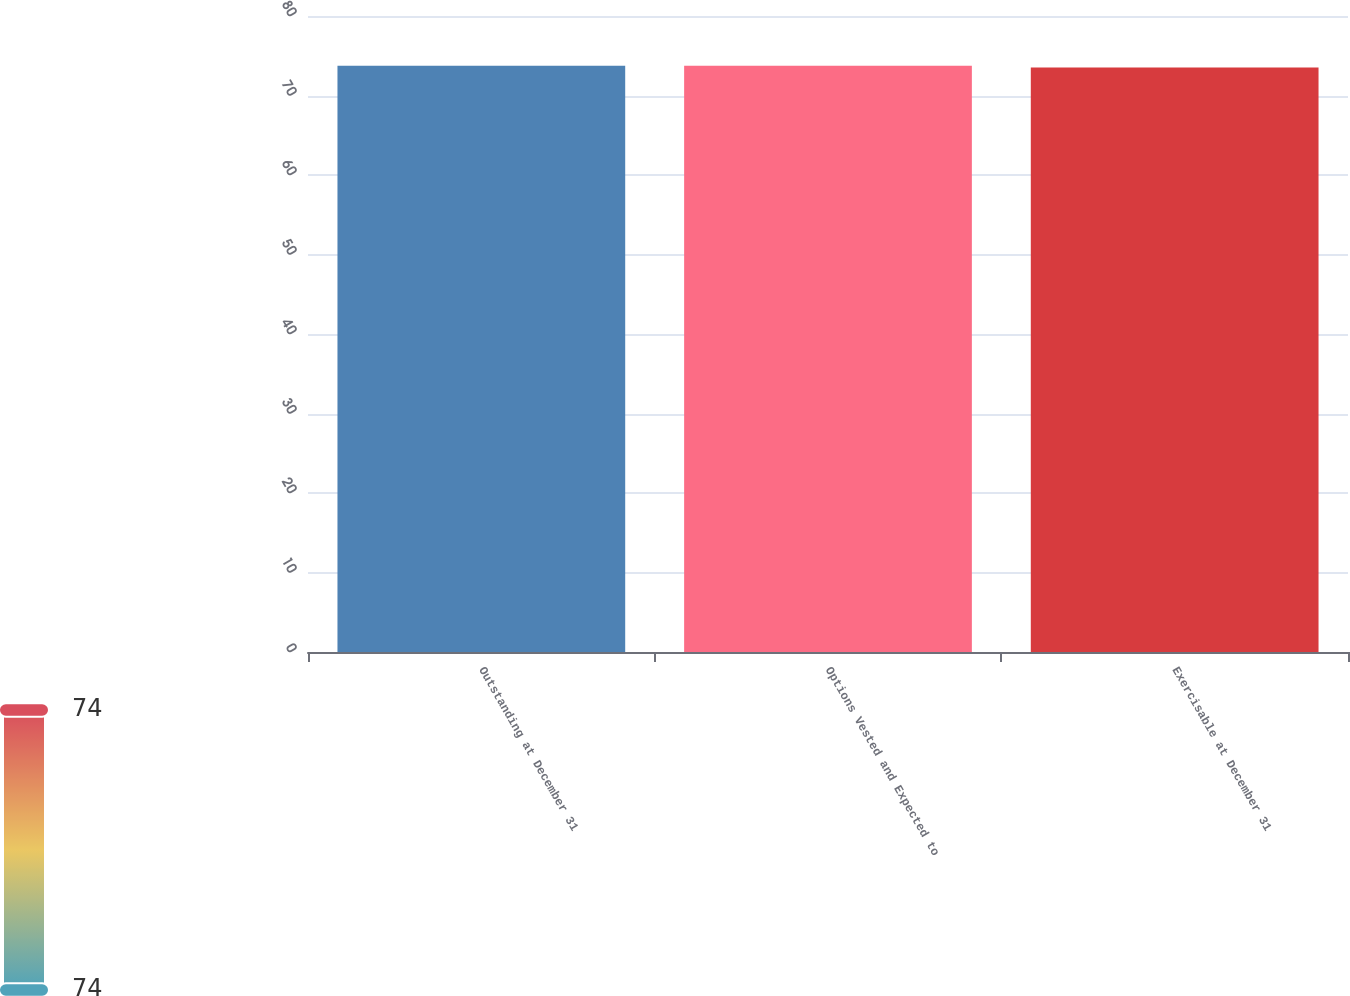<chart> <loc_0><loc_0><loc_500><loc_500><bar_chart><fcel>Outstanding at December 31<fcel>Options Vested and Expected to<fcel>Exercisable at December 31<nl><fcel>73.73<fcel>73.75<fcel>73.52<nl></chart> 